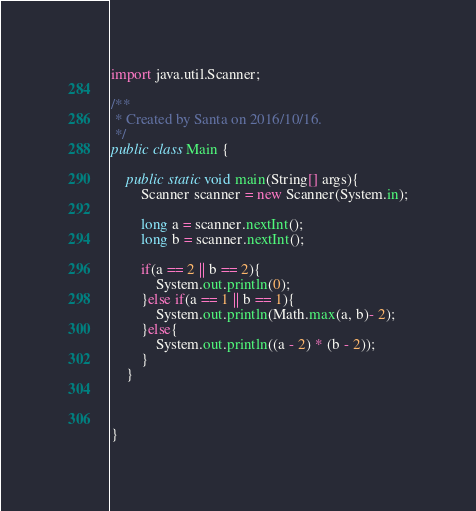Convert code to text. <code><loc_0><loc_0><loc_500><loc_500><_Java_>import java.util.Scanner;

/**
 * Created by Santa on 2016/10/16.
 */
public class Main {

    public static void main(String[] args){
        Scanner scanner = new Scanner(System.in);

        long a = scanner.nextInt();
        long b = scanner.nextInt();

        if(a == 2 || b == 2){
            System.out.println(0);
        }else if(a == 1 || b == 1){
            System.out.println(Math.max(a, b)- 2);
        }else{
            System.out.println((a - 2) * (b - 2));
        }
    }



}


</code> 